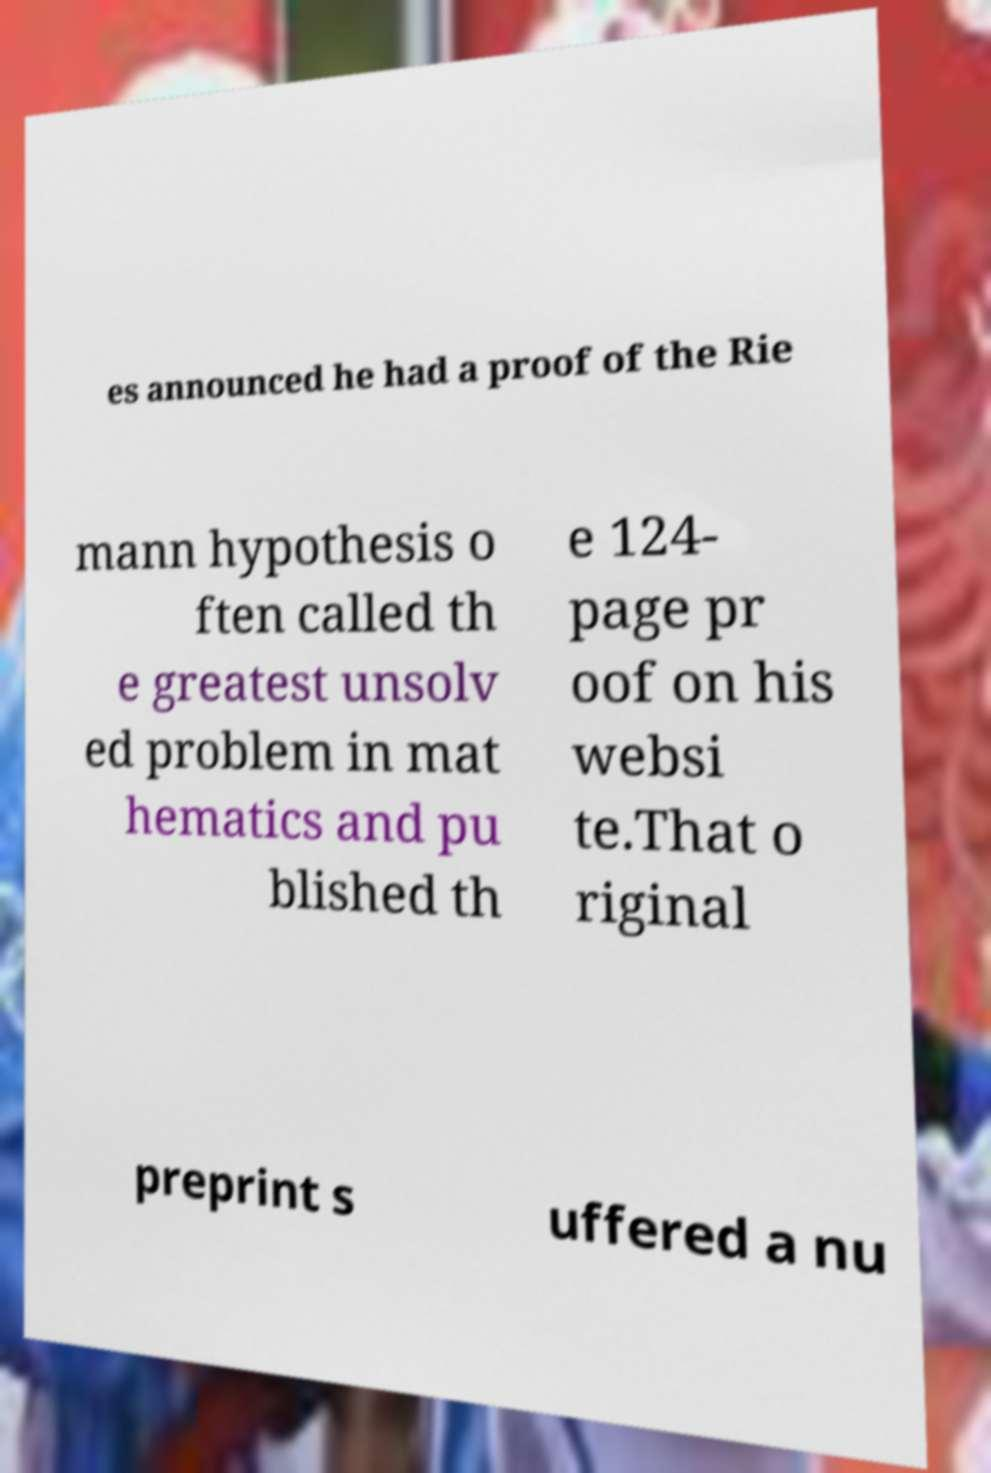There's text embedded in this image that I need extracted. Can you transcribe it verbatim? es announced he had a proof of the Rie mann hypothesis o ften called th e greatest unsolv ed problem in mat hematics and pu blished th e 124- page pr oof on his websi te.That o riginal preprint s uffered a nu 